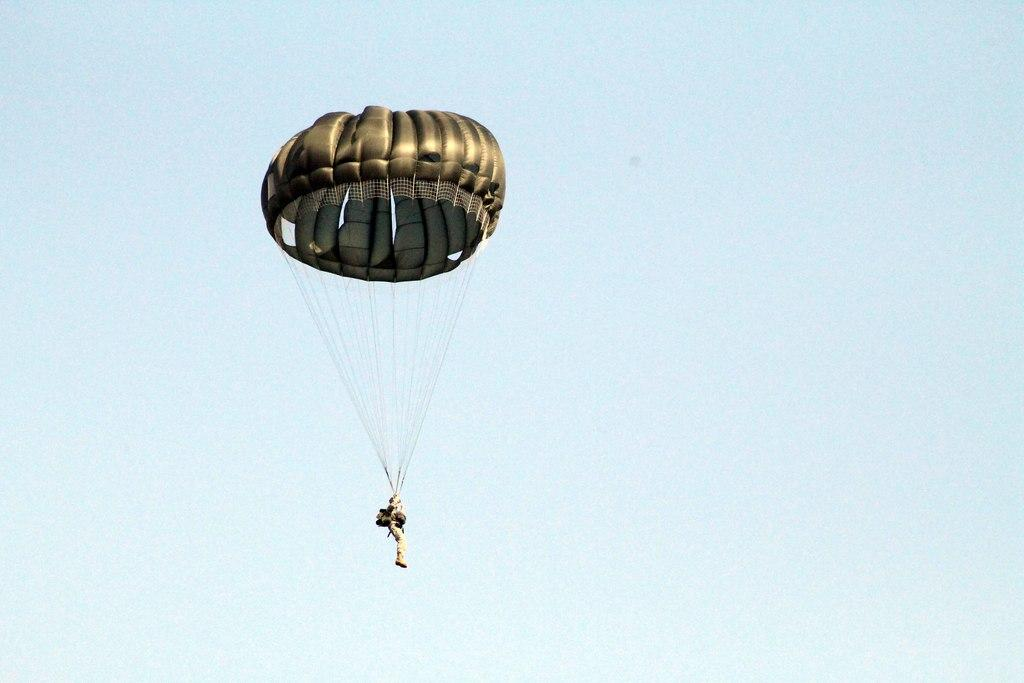What is flying in the air in the image? There is a parachute flying in the air in the image. What can be seen in the background of the image? The sky is visible in the background of the image. What flavor of sock is the person wearing while parachuting in the image? There is no information about socks or flavors in the image, as it only shows a parachute flying in the air. 